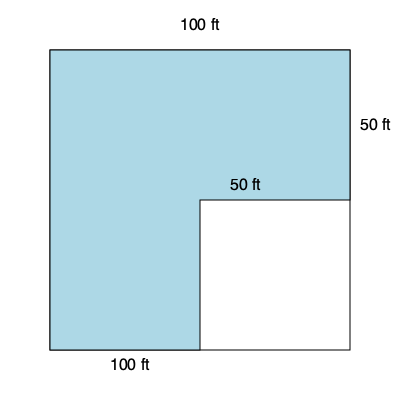As a real estate agent, you're listing an irregularly shaped property. Given the aerial view above, estimate the total square footage of the lot. All angles are 90 degrees, and dimensions are as labeled. What is the total area of the property? To calculate the total area of this irregularly shaped property, we can break it down into rectangular sections:

1. First, identify the two rectangles that make up the property:
   - Rectangle A: The full width of the property (100 ft x 50 ft)
   - Rectangle B: The remaining L-shaped portion (50 ft x 50 ft)

2. Calculate the area of Rectangle A:
   $A_A = 100 \text{ ft} \times 50 \text{ ft} = 5,000 \text{ sq ft}$

3. Calculate the area of Rectangle B:
   $A_B = 50 \text{ ft} \times 50 \text{ ft} = 2,500 \text{ sq ft}$

4. Sum the areas of both rectangles to get the total area:
   $A_{\text{total}} = A_A + A_B = 5,000 \text{ sq ft} + 2,500 \text{ sq ft} = 7,500 \text{ sq ft}$

Therefore, the total area of the irregularly shaped property lot is 7,500 square feet.
Answer: 7,500 square feet 